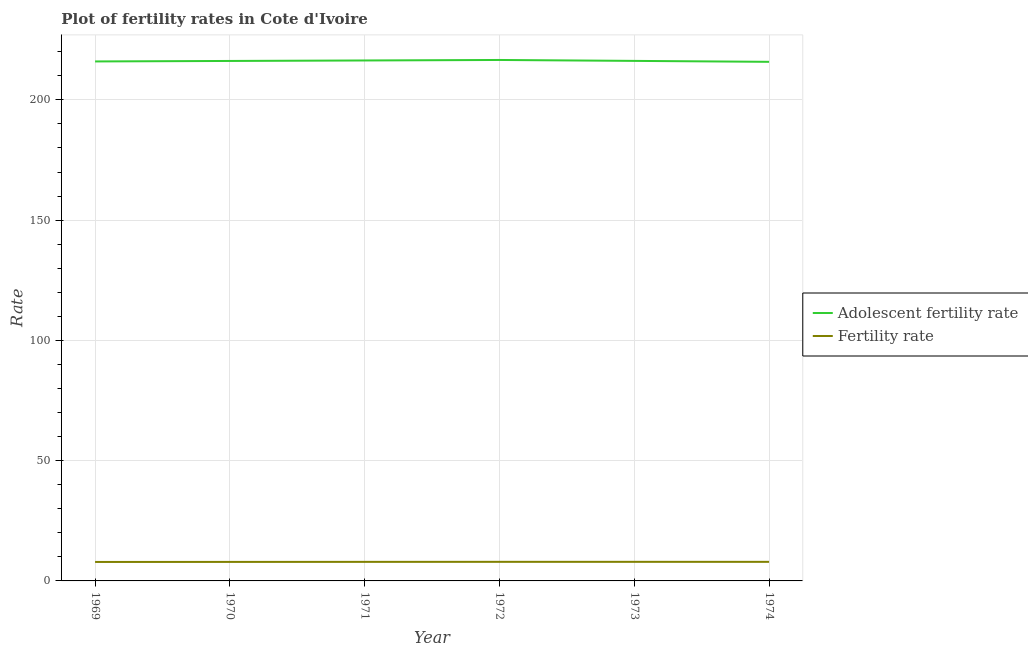How many different coloured lines are there?
Ensure brevity in your answer.  2. Is the number of lines equal to the number of legend labels?
Make the answer very short. Yes. What is the fertility rate in 1972?
Your answer should be compact. 7.94. Across all years, what is the maximum fertility rate?
Ensure brevity in your answer.  7.94. Across all years, what is the minimum adolescent fertility rate?
Your response must be concise. 215.82. In which year was the fertility rate minimum?
Offer a terse response. 1969. What is the total fertility rate in the graph?
Provide a succinct answer. 47.53. What is the difference between the adolescent fertility rate in 1971 and that in 1973?
Your answer should be compact. 0.18. What is the difference between the fertility rate in 1972 and the adolescent fertility rate in 1969?
Your answer should be compact. -208.04. What is the average adolescent fertility rate per year?
Your response must be concise. 216.19. In the year 1969, what is the difference between the adolescent fertility rate and fertility rate?
Ensure brevity in your answer.  208.1. In how many years, is the fertility rate greater than 100?
Your response must be concise. 0. What is the ratio of the fertility rate in 1971 to that in 1973?
Your response must be concise. 1. What is the difference between the highest and the second highest adolescent fertility rate?
Provide a short and direct response. 0.2. What is the difference between the highest and the lowest adolescent fertility rate?
Your answer should be compact. 0.77. In how many years, is the fertility rate greater than the average fertility rate taken over all years?
Give a very brief answer. 4. Is the sum of the adolescent fertility rate in 1970 and 1973 greater than the maximum fertility rate across all years?
Keep it short and to the point. Yes. Does the fertility rate monotonically increase over the years?
Offer a very short reply. No. Is the adolescent fertility rate strictly less than the fertility rate over the years?
Provide a succinct answer. No. How many years are there in the graph?
Offer a terse response. 6. What is the difference between two consecutive major ticks on the Y-axis?
Make the answer very short. 50. Are the values on the major ticks of Y-axis written in scientific E-notation?
Provide a short and direct response. No. Does the graph contain any zero values?
Ensure brevity in your answer.  No. Does the graph contain grids?
Ensure brevity in your answer.  Yes. Where does the legend appear in the graph?
Give a very brief answer. Center right. How many legend labels are there?
Provide a succinct answer. 2. How are the legend labels stacked?
Provide a short and direct response. Vertical. What is the title of the graph?
Make the answer very short. Plot of fertility rates in Cote d'Ivoire. What is the label or title of the Y-axis?
Your answer should be very brief. Rate. What is the Rate of Adolescent fertility rate in 1969?
Ensure brevity in your answer.  215.98. What is the Rate in Fertility rate in 1969?
Keep it short and to the point. 7.88. What is the Rate in Adolescent fertility rate in 1970?
Make the answer very short. 216.18. What is the Rate of Fertility rate in 1970?
Make the answer very short. 7.91. What is the Rate in Adolescent fertility rate in 1971?
Provide a short and direct response. 216.39. What is the Rate of Fertility rate in 1971?
Ensure brevity in your answer.  7.93. What is the Rate in Adolescent fertility rate in 1972?
Your answer should be very brief. 216.59. What is the Rate of Fertility rate in 1972?
Your answer should be very brief. 7.94. What is the Rate of Adolescent fertility rate in 1973?
Your response must be concise. 216.21. What is the Rate of Fertility rate in 1973?
Offer a very short reply. 7.94. What is the Rate of Adolescent fertility rate in 1974?
Your answer should be very brief. 215.82. What is the Rate of Fertility rate in 1974?
Your response must be concise. 7.93. Across all years, what is the maximum Rate in Adolescent fertility rate?
Provide a succinct answer. 216.59. Across all years, what is the maximum Rate of Fertility rate?
Provide a succinct answer. 7.94. Across all years, what is the minimum Rate in Adolescent fertility rate?
Your answer should be compact. 215.82. Across all years, what is the minimum Rate of Fertility rate?
Your answer should be very brief. 7.88. What is the total Rate in Adolescent fertility rate in the graph?
Offer a very short reply. 1297.16. What is the total Rate of Fertility rate in the graph?
Make the answer very short. 47.53. What is the difference between the Rate of Adolescent fertility rate in 1969 and that in 1970?
Provide a succinct answer. -0.2. What is the difference between the Rate of Fertility rate in 1969 and that in 1970?
Your answer should be very brief. -0.03. What is the difference between the Rate in Adolescent fertility rate in 1969 and that in 1971?
Provide a succinct answer. -0.41. What is the difference between the Rate in Fertility rate in 1969 and that in 1971?
Keep it short and to the point. -0.04. What is the difference between the Rate in Adolescent fertility rate in 1969 and that in 1972?
Make the answer very short. -0.61. What is the difference between the Rate in Fertility rate in 1969 and that in 1972?
Provide a succinct answer. -0.05. What is the difference between the Rate of Adolescent fertility rate in 1969 and that in 1973?
Your answer should be compact. -0.23. What is the difference between the Rate in Fertility rate in 1969 and that in 1973?
Your response must be concise. -0.06. What is the difference between the Rate in Adolescent fertility rate in 1969 and that in 1974?
Your answer should be very brief. 0.16. What is the difference between the Rate in Fertility rate in 1969 and that in 1974?
Make the answer very short. -0.05. What is the difference between the Rate of Adolescent fertility rate in 1970 and that in 1971?
Provide a short and direct response. -0.2. What is the difference between the Rate of Fertility rate in 1970 and that in 1971?
Keep it short and to the point. -0.02. What is the difference between the Rate of Adolescent fertility rate in 1970 and that in 1972?
Provide a short and direct response. -0.41. What is the difference between the Rate of Fertility rate in 1970 and that in 1972?
Your answer should be very brief. -0.03. What is the difference between the Rate in Adolescent fertility rate in 1970 and that in 1973?
Your answer should be compact. -0.02. What is the difference between the Rate of Fertility rate in 1970 and that in 1973?
Offer a terse response. -0.03. What is the difference between the Rate in Adolescent fertility rate in 1970 and that in 1974?
Provide a short and direct response. 0.36. What is the difference between the Rate in Fertility rate in 1970 and that in 1974?
Keep it short and to the point. -0.03. What is the difference between the Rate of Adolescent fertility rate in 1971 and that in 1972?
Give a very brief answer. -0.2. What is the difference between the Rate in Fertility rate in 1971 and that in 1972?
Ensure brevity in your answer.  -0.01. What is the difference between the Rate in Adolescent fertility rate in 1971 and that in 1973?
Give a very brief answer. 0.18. What is the difference between the Rate in Fertility rate in 1971 and that in 1973?
Ensure brevity in your answer.  -0.01. What is the difference between the Rate in Adolescent fertility rate in 1971 and that in 1974?
Provide a succinct answer. 0.56. What is the difference between the Rate in Fertility rate in 1971 and that in 1974?
Your response must be concise. -0.01. What is the difference between the Rate in Adolescent fertility rate in 1972 and that in 1973?
Give a very brief answer. 0.38. What is the difference between the Rate in Fertility rate in 1972 and that in 1973?
Your answer should be compact. -0. What is the difference between the Rate in Adolescent fertility rate in 1972 and that in 1974?
Provide a succinct answer. 0.77. What is the difference between the Rate in Fertility rate in 1972 and that in 1974?
Your answer should be very brief. 0. What is the difference between the Rate in Adolescent fertility rate in 1973 and that in 1974?
Provide a short and direct response. 0.38. What is the difference between the Rate in Fertility rate in 1973 and that in 1974?
Give a very brief answer. 0.01. What is the difference between the Rate of Adolescent fertility rate in 1969 and the Rate of Fertility rate in 1970?
Your answer should be compact. 208.07. What is the difference between the Rate of Adolescent fertility rate in 1969 and the Rate of Fertility rate in 1971?
Your response must be concise. 208.05. What is the difference between the Rate of Adolescent fertility rate in 1969 and the Rate of Fertility rate in 1972?
Your answer should be very brief. 208.04. What is the difference between the Rate of Adolescent fertility rate in 1969 and the Rate of Fertility rate in 1973?
Your response must be concise. 208.04. What is the difference between the Rate of Adolescent fertility rate in 1969 and the Rate of Fertility rate in 1974?
Your answer should be very brief. 208.05. What is the difference between the Rate of Adolescent fertility rate in 1970 and the Rate of Fertility rate in 1971?
Ensure brevity in your answer.  208.26. What is the difference between the Rate of Adolescent fertility rate in 1970 and the Rate of Fertility rate in 1972?
Give a very brief answer. 208.25. What is the difference between the Rate in Adolescent fertility rate in 1970 and the Rate in Fertility rate in 1973?
Provide a succinct answer. 208.24. What is the difference between the Rate of Adolescent fertility rate in 1970 and the Rate of Fertility rate in 1974?
Your response must be concise. 208.25. What is the difference between the Rate of Adolescent fertility rate in 1971 and the Rate of Fertility rate in 1972?
Make the answer very short. 208.45. What is the difference between the Rate of Adolescent fertility rate in 1971 and the Rate of Fertility rate in 1973?
Ensure brevity in your answer.  208.45. What is the difference between the Rate in Adolescent fertility rate in 1971 and the Rate in Fertility rate in 1974?
Give a very brief answer. 208.45. What is the difference between the Rate in Adolescent fertility rate in 1972 and the Rate in Fertility rate in 1973?
Your answer should be compact. 208.65. What is the difference between the Rate of Adolescent fertility rate in 1972 and the Rate of Fertility rate in 1974?
Provide a short and direct response. 208.66. What is the difference between the Rate of Adolescent fertility rate in 1973 and the Rate of Fertility rate in 1974?
Your answer should be very brief. 208.27. What is the average Rate of Adolescent fertility rate per year?
Your answer should be very brief. 216.19. What is the average Rate of Fertility rate per year?
Your answer should be compact. 7.92. In the year 1969, what is the difference between the Rate of Adolescent fertility rate and Rate of Fertility rate?
Your response must be concise. 208.1. In the year 1970, what is the difference between the Rate in Adolescent fertility rate and Rate in Fertility rate?
Keep it short and to the point. 208.28. In the year 1971, what is the difference between the Rate in Adolescent fertility rate and Rate in Fertility rate?
Your response must be concise. 208.46. In the year 1972, what is the difference between the Rate of Adolescent fertility rate and Rate of Fertility rate?
Offer a very short reply. 208.65. In the year 1973, what is the difference between the Rate of Adolescent fertility rate and Rate of Fertility rate?
Give a very brief answer. 208.26. In the year 1974, what is the difference between the Rate in Adolescent fertility rate and Rate in Fertility rate?
Provide a short and direct response. 207.89. What is the ratio of the Rate in Adolescent fertility rate in 1969 to that in 1970?
Offer a very short reply. 1. What is the ratio of the Rate in Fertility rate in 1969 to that in 1970?
Provide a short and direct response. 1. What is the ratio of the Rate of Adolescent fertility rate in 1969 to that in 1971?
Your response must be concise. 1. What is the ratio of the Rate in Fertility rate in 1969 to that in 1971?
Provide a short and direct response. 0.99. What is the ratio of the Rate in Fertility rate in 1969 to that in 1972?
Provide a succinct answer. 0.99. What is the ratio of the Rate in Fertility rate in 1969 to that in 1973?
Offer a terse response. 0.99. What is the ratio of the Rate of Fertility rate in 1969 to that in 1974?
Make the answer very short. 0.99. What is the ratio of the Rate in Adolescent fertility rate in 1970 to that in 1972?
Keep it short and to the point. 1. What is the ratio of the Rate of Fertility rate in 1970 to that in 1973?
Make the answer very short. 1. What is the ratio of the Rate of Adolescent fertility rate in 1970 to that in 1974?
Give a very brief answer. 1. What is the ratio of the Rate of Adolescent fertility rate in 1971 to that in 1972?
Provide a short and direct response. 1. What is the ratio of the Rate of Adolescent fertility rate in 1971 to that in 1974?
Your answer should be compact. 1. What is the ratio of the Rate in Adolescent fertility rate in 1972 to that in 1974?
Offer a very short reply. 1. What is the ratio of the Rate of Fertility rate in 1972 to that in 1974?
Make the answer very short. 1. What is the difference between the highest and the second highest Rate of Adolescent fertility rate?
Your answer should be compact. 0.2. What is the difference between the highest and the second highest Rate in Fertility rate?
Keep it short and to the point. 0. What is the difference between the highest and the lowest Rate of Adolescent fertility rate?
Offer a terse response. 0.77. What is the difference between the highest and the lowest Rate of Fertility rate?
Offer a very short reply. 0.06. 